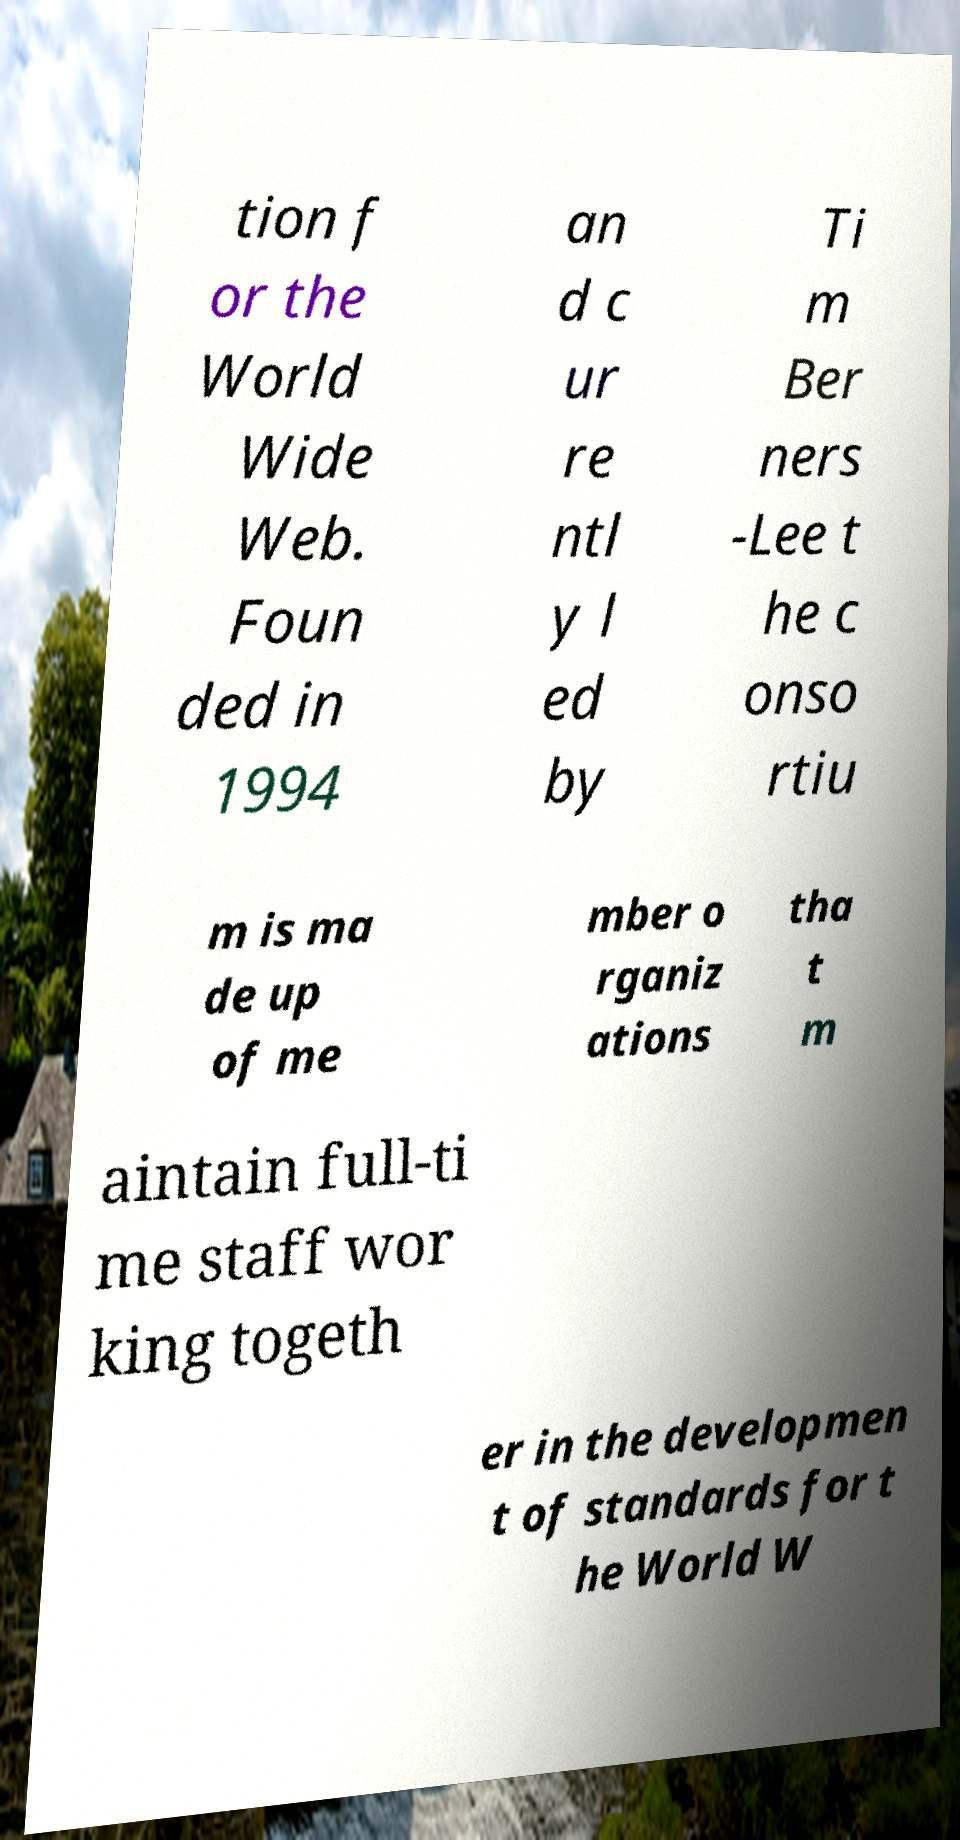There's text embedded in this image that I need extracted. Can you transcribe it verbatim? tion f or the World Wide Web. Foun ded in 1994 an d c ur re ntl y l ed by Ti m Ber ners -Lee t he c onso rtiu m is ma de up of me mber o rganiz ations tha t m aintain full-ti me staff wor king togeth er in the developmen t of standards for t he World W 